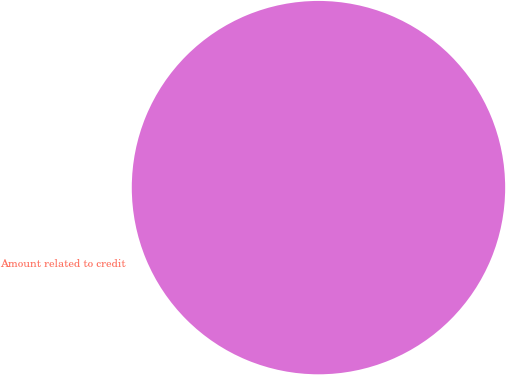<chart> <loc_0><loc_0><loc_500><loc_500><pie_chart><fcel>Amount related to credit<nl><fcel>100.0%<nl></chart> 